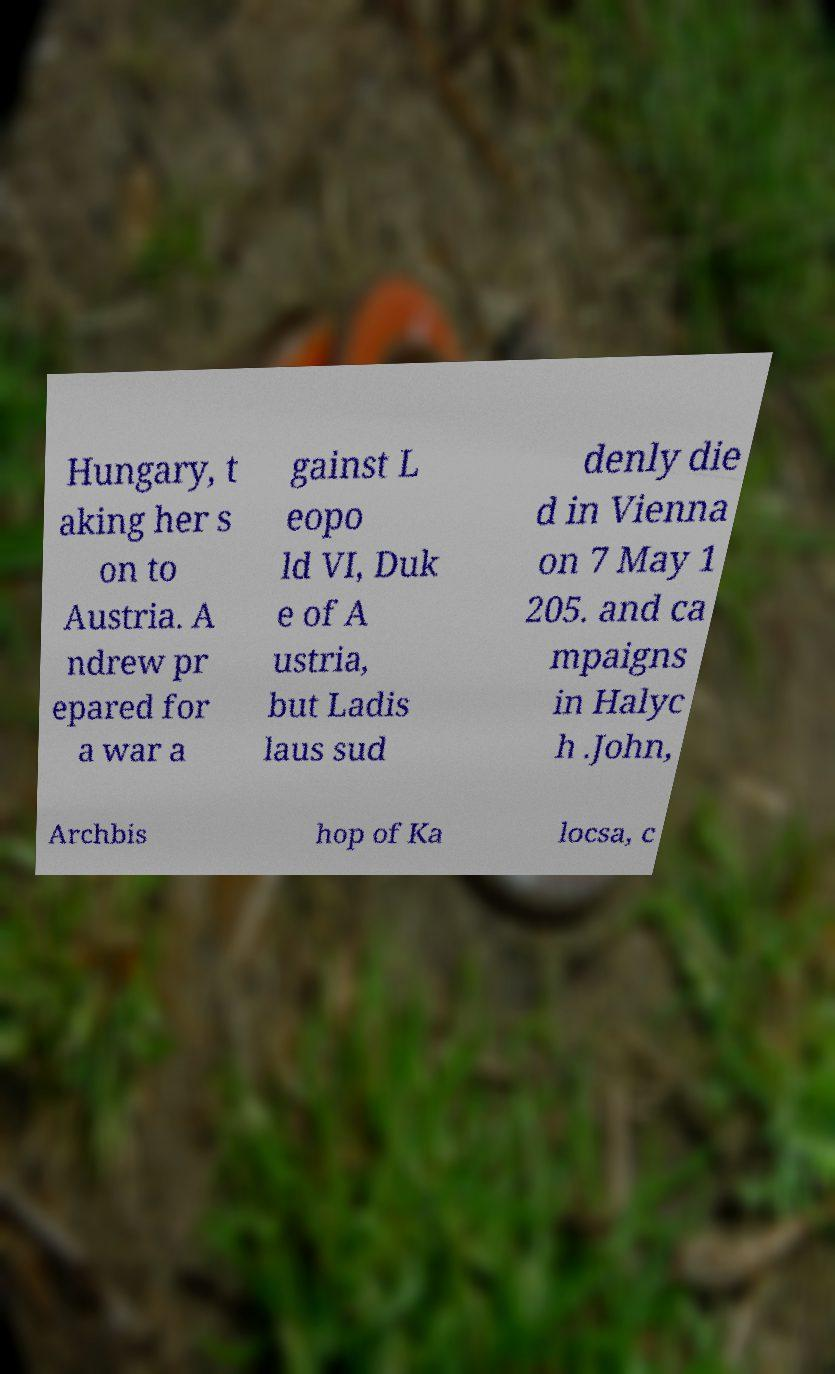Could you extract and type out the text from this image? Hungary, t aking her s on to Austria. A ndrew pr epared for a war a gainst L eopo ld VI, Duk e of A ustria, but Ladis laus sud denly die d in Vienna on 7 May 1 205. and ca mpaigns in Halyc h .John, Archbis hop of Ka locsa, c 